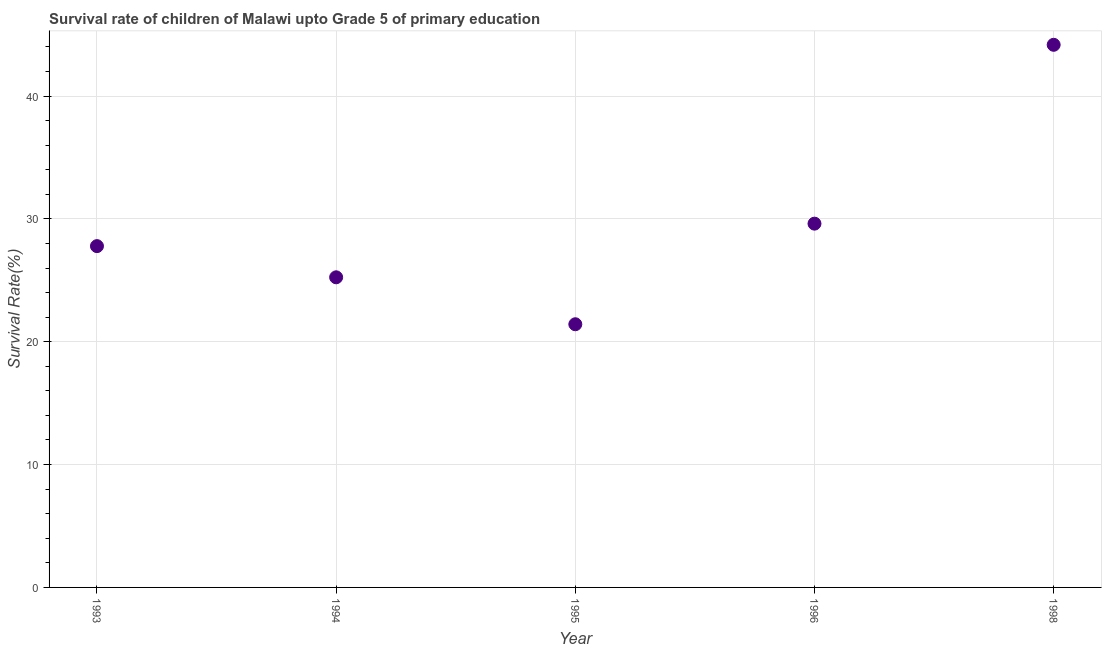What is the survival rate in 1996?
Make the answer very short. 29.61. Across all years, what is the maximum survival rate?
Ensure brevity in your answer.  44.17. Across all years, what is the minimum survival rate?
Make the answer very short. 21.42. In which year was the survival rate maximum?
Your answer should be very brief. 1998. What is the sum of the survival rate?
Offer a very short reply. 148.22. What is the difference between the survival rate in 1996 and 1998?
Make the answer very short. -14.56. What is the average survival rate per year?
Give a very brief answer. 29.64. What is the median survival rate?
Make the answer very short. 27.78. What is the ratio of the survival rate in 1995 to that in 1996?
Give a very brief answer. 0.72. Is the difference between the survival rate in 1993 and 1994 greater than the difference between any two years?
Keep it short and to the point. No. What is the difference between the highest and the second highest survival rate?
Provide a succinct answer. 14.56. What is the difference between the highest and the lowest survival rate?
Your answer should be compact. 22.75. In how many years, is the survival rate greater than the average survival rate taken over all years?
Provide a succinct answer. 1. How many dotlines are there?
Your response must be concise. 1. What is the difference between two consecutive major ticks on the Y-axis?
Offer a very short reply. 10. Are the values on the major ticks of Y-axis written in scientific E-notation?
Offer a very short reply. No. Does the graph contain grids?
Your answer should be very brief. Yes. What is the title of the graph?
Keep it short and to the point. Survival rate of children of Malawi upto Grade 5 of primary education. What is the label or title of the X-axis?
Your response must be concise. Year. What is the label or title of the Y-axis?
Provide a short and direct response. Survival Rate(%). What is the Survival Rate(%) in 1993?
Provide a succinct answer. 27.78. What is the Survival Rate(%) in 1994?
Make the answer very short. 25.24. What is the Survival Rate(%) in 1995?
Keep it short and to the point. 21.42. What is the Survival Rate(%) in 1996?
Make the answer very short. 29.61. What is the Survival Rate(%) in 1998?
Your answer should be compact. 44.17. What is the difference between the Survival Rate(%) in 1993 and 1994?
Ensure brevity in your answer.  2.54. What is the difference between the Survival Rate(%) in 1993 and 1995?
Give a very brief answer. 6.36. What is the difference between the Survival Rate(%) in 1993 and 1996?
Give a very brief answer. -1.83. What is the difference between the Survival Rate(%) in 1993 and 1998?
Keep it short and to the point. -16.39. What is the difference between the Survival Rate(%) in 1994 and 1995?
Ensure brevity in your answer.  3.82. What is the difference between the Survival Rate(%) in 1994 and 1996?
Give a very brief answer. -4.37. What is the difference between the Survival Rate(%) in 1994 and 1998?
Make the answer very short. -18.93. What is the difference between the Survival Rate(%) in 1995 and 1996?
Your answer should be compact. -8.19. What is the difference between the Survival Rate(%) in 1995 and 1998?
Offer a very short reply. -22.75. What is the difference between the Survival Rate(%) in 1996 and 1998?
Your answer should be compact. -14.56. What is the ratio of the Survival Rate(%) in 1993 to that in 1994?
Your answer should be compact. 1.1. What is the ratio of the Survival Rate(%) in 1993 to that in 1995?
Make the answer very short. 1.3. What is the ratio of the Survival Rate(%) in 1993 to that in 1996?
Your response must be concise. 0.94. What is the ratio of the Survival Rate(%) in 1993 to that in 1998?
Offer a very short reply. 0.63. What is the ratio of the Survival Rate(%) in 1994 to that in 1995?
Provide a succinct answer. 1.18. What is the ratio of the Survival Rate(%) in 1994 to that in 1996?
Provide a short and direct response. 0.85. What is the ratio of the Survival Rate(%) in 1994 to that in 1998?
Keep it short and to the point. 0.57. What is the ratio of the Survival Rate(%) in 1995 to that in 1996?
Provide a short and direct response. 0.72. What is the ratio of the Survival Rate(%) in 1995 to that in 1998?
Your answer should be compact. 0.48. What is the ratio of the Survival Rate(%) in 1996 to that in 1998?
Your answer should be compact. 0.67. 